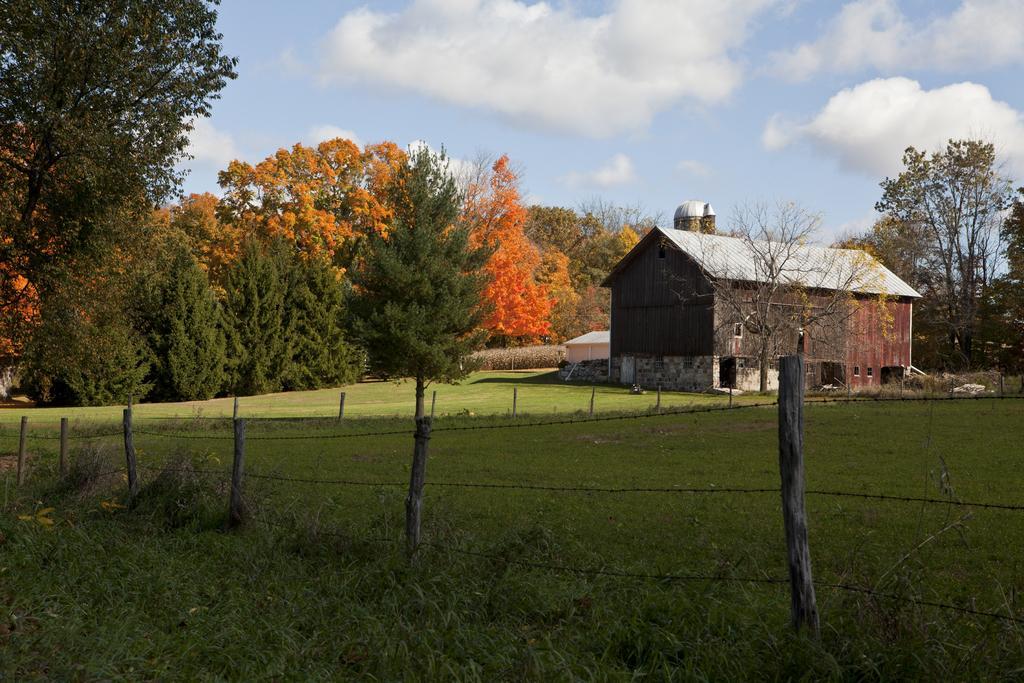In one or two sentences, can you explain what this image depicts? As we can see in the image there is grass, fence and house. In the background there are trees. At the top there is sky and there are clouds. 